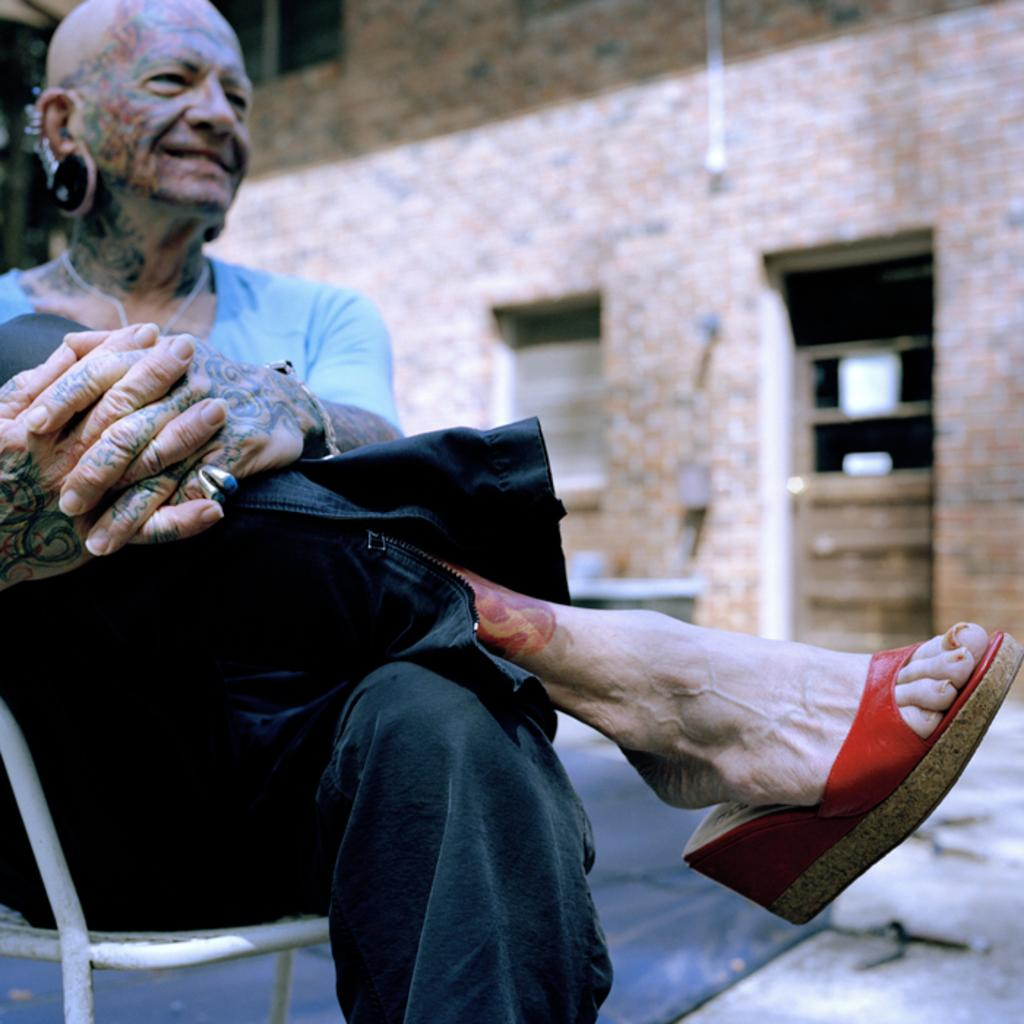What is the person in the image doing? The person is sitting on a chair on the left side of the image. What can be seen behind the person? There is a wall in the background of the image. What type of vest is the hen wearing in the image? There is no hen or vest present in the image. 